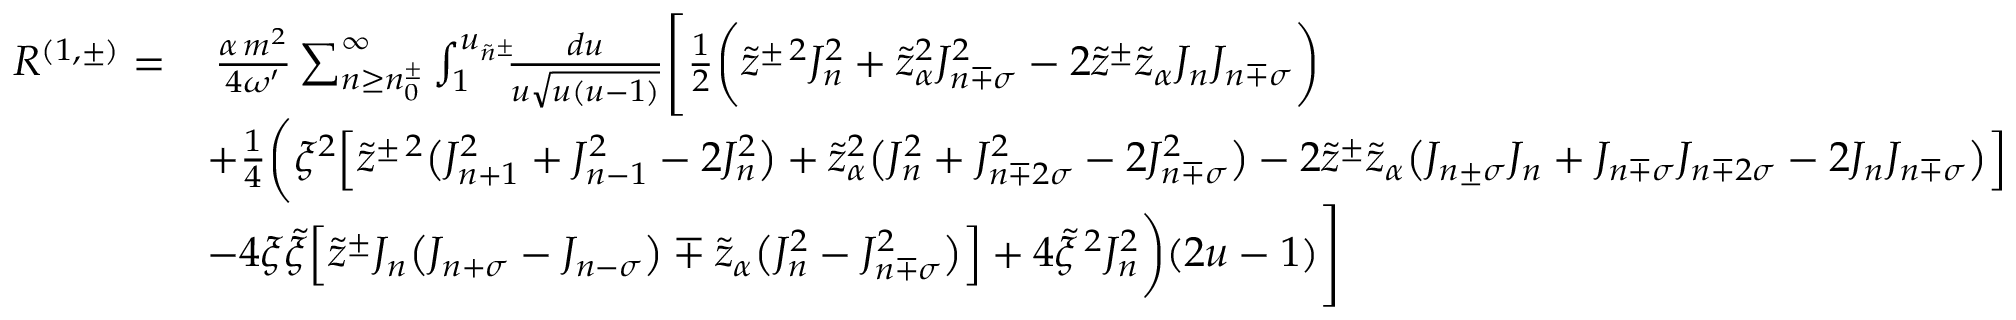<formula> <loc_0><loc_0><loc_500><loc_500>\begin{array} { r l } { R ^ { ( 1 , \pm ) } = } & { \, \frac { \alpha \, m ^ { 2 } } { 4 \omega ^ { \prime } } \sum _ { n \geq n _ { 0 } ^ { \pm } } ^ { \infty } \int _ { 1 } ^ { u _ { \tilde { n } ^ { \pm } } } \, \frac { d u } { u \sqrt { u ( u - 1 ) } } \left [ \frac { 1 } { 2 } \left ( \tilde { z } ^ { \pm \, 2 } J _ { n } ^ { 2 } + \tilde { z } _ { \alpha } ^ { 2 } J _ { n \mp \sigma } ^ { 2 } - 2 \tilde { z } ^ { \pm } \tilde { z } _ { \alpha } J _ { n } J _ { n \mp \sigma } \right ) } \\ & { + \frac { 1 } { 4 } \left ( \xi ^ { 2 } \left [ \tilde { z } ^ { \pm \, 2 } \left ( J _ { n + 1 } ^ { 2 } + J _ { n - 1 } ^ { 2 } - 2 J _ { n } ^ { 2 } \right ) + \tilde { z } _ { \alpha } ^ { 2 } \left ( J _ { n } ^ { 2 } + J _ { n \mp 2 \sigma } ^ { 2 } - 2 J _ { n \mp \sigma } ^ { 2 } \right ) - 2 \tilde { z } ^ { \pm } \tilde { z } _ { \alpha } \left ( J _ { n \pm \sigma } J _ { n } + J _ { n \mp \sigma } J _ { n \mp 2 \sigma } - 2 J _ { n } J _ { n \mp \sigma } \right ) \right ] } \\ & { - 4 \xi \tilde { \xi } \left [ \tilde { z } ^ { \pm } J _ { n } \left ( J _ { n + \sigma } - J _ { n - \sigma } \right ) \mp \tilde { z } _ { \alpha } \left ( J _ { n } ^ { 2 } - J _ { n \mp \sigma } ^ { 2 } \right ) \right ] + 4 \tilde { \xi } ^ { \, 2 } J _ { n } ^ { 2 } \right ) ( 2 u - 1 ) \right ] } \end{array}</formula> 